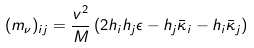Convert formula to latex. <formula><loc_0><loc_0><loc_500><loc_500>( m _ { \nu } ) _ { i j } = \frac { v ^ { 2 } } { M } \left ( 2 h _ { i } h _ { j } \epsilon - h _ { j } \bar { \kappa } _ { i } - h _ { i } \bar { \kappa } _ { j } \right )</formula> 